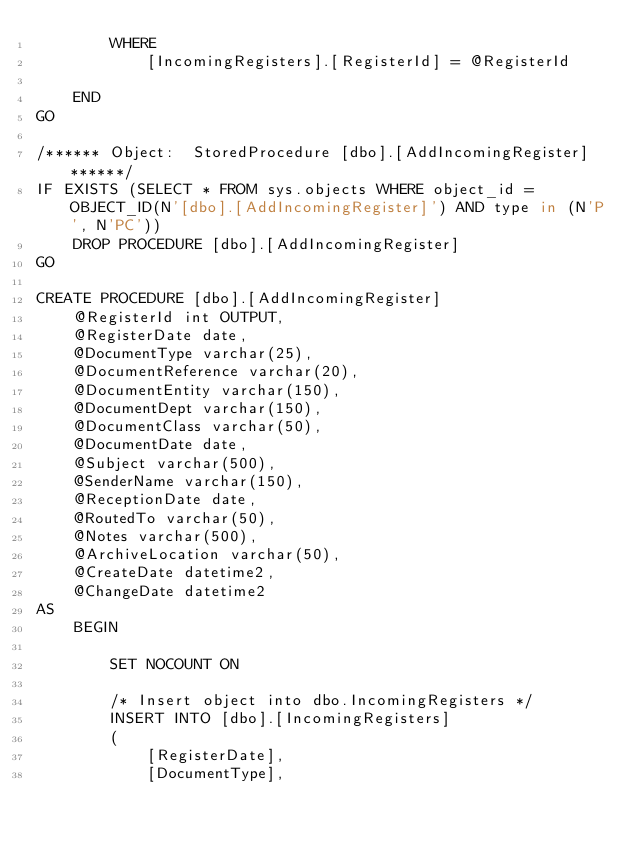<code> <loc_0><loc_0><loc_500><loc_500><_SQL_>        WHERE
            [IncomingRegisters].[RegisterId] = @RegisterId

    END
GO

/****** Object:  StoredProcedure [dbo].[AddIncomingRegister] ******/
IF EXISTS (SELECT * FROM sys.objects WHERE object_id = OBJECT_ID(N'[dbo].[AddIncomingRegister]') AND type in (N'P', N'PC'))
    DROP PROCEDURE [dbo].[AddIncomingRegister]
GO

CREATE PROCEDURE [dbo].[AddIncomingRegister]
    @RegisterId int OUTPUT,
    @RegisterDate date,
    @DocumentType varchar(25),
    @DocumentReference varchar(20),
    @DocumentEntity varchar(150),
    @DocumentDept varchar(150),
    @DocumentClass varchar(50),
    @DocumentDate date,
    @Subject varchar(500),
    @SenderName varchar(150),
    @ReceptionDate date,
    @RoutedTo varchar(50),
    @Notes varchar(500),
    @ArchiveLocation varchar(50),
    @CreateDate datetime2,
    @ChangeDate datetime2
AS
    BEGIN

        SET NOCOUNT ON

        /* Insert object into dbo.IncomingRegisters */
        INSERT INTO [dbo].[IncomingRegisters]
        (
            [RegisterDate],
            [DocumentType],</code> 